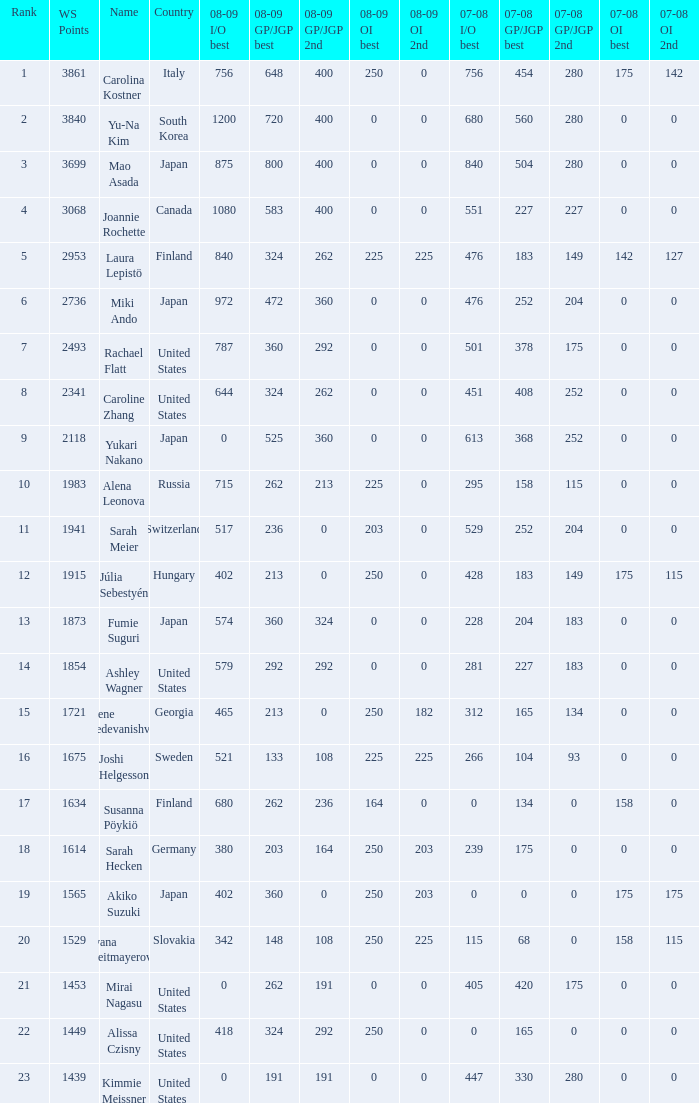In the 07-08 gp/jgp season, what was the total score for mao asada when she secured the 2nd position? 280.0. 